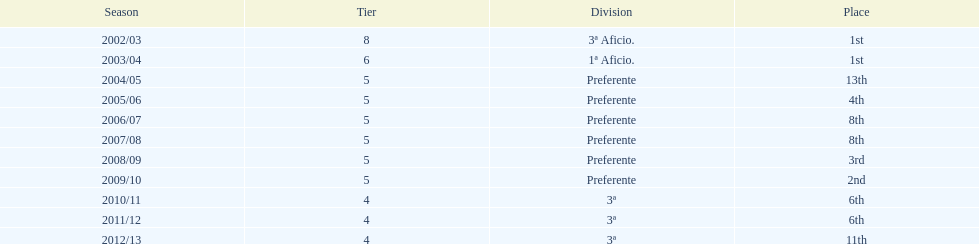What is the total number of times internacional de madrid cf finished their season as the leader of their division? 2. 